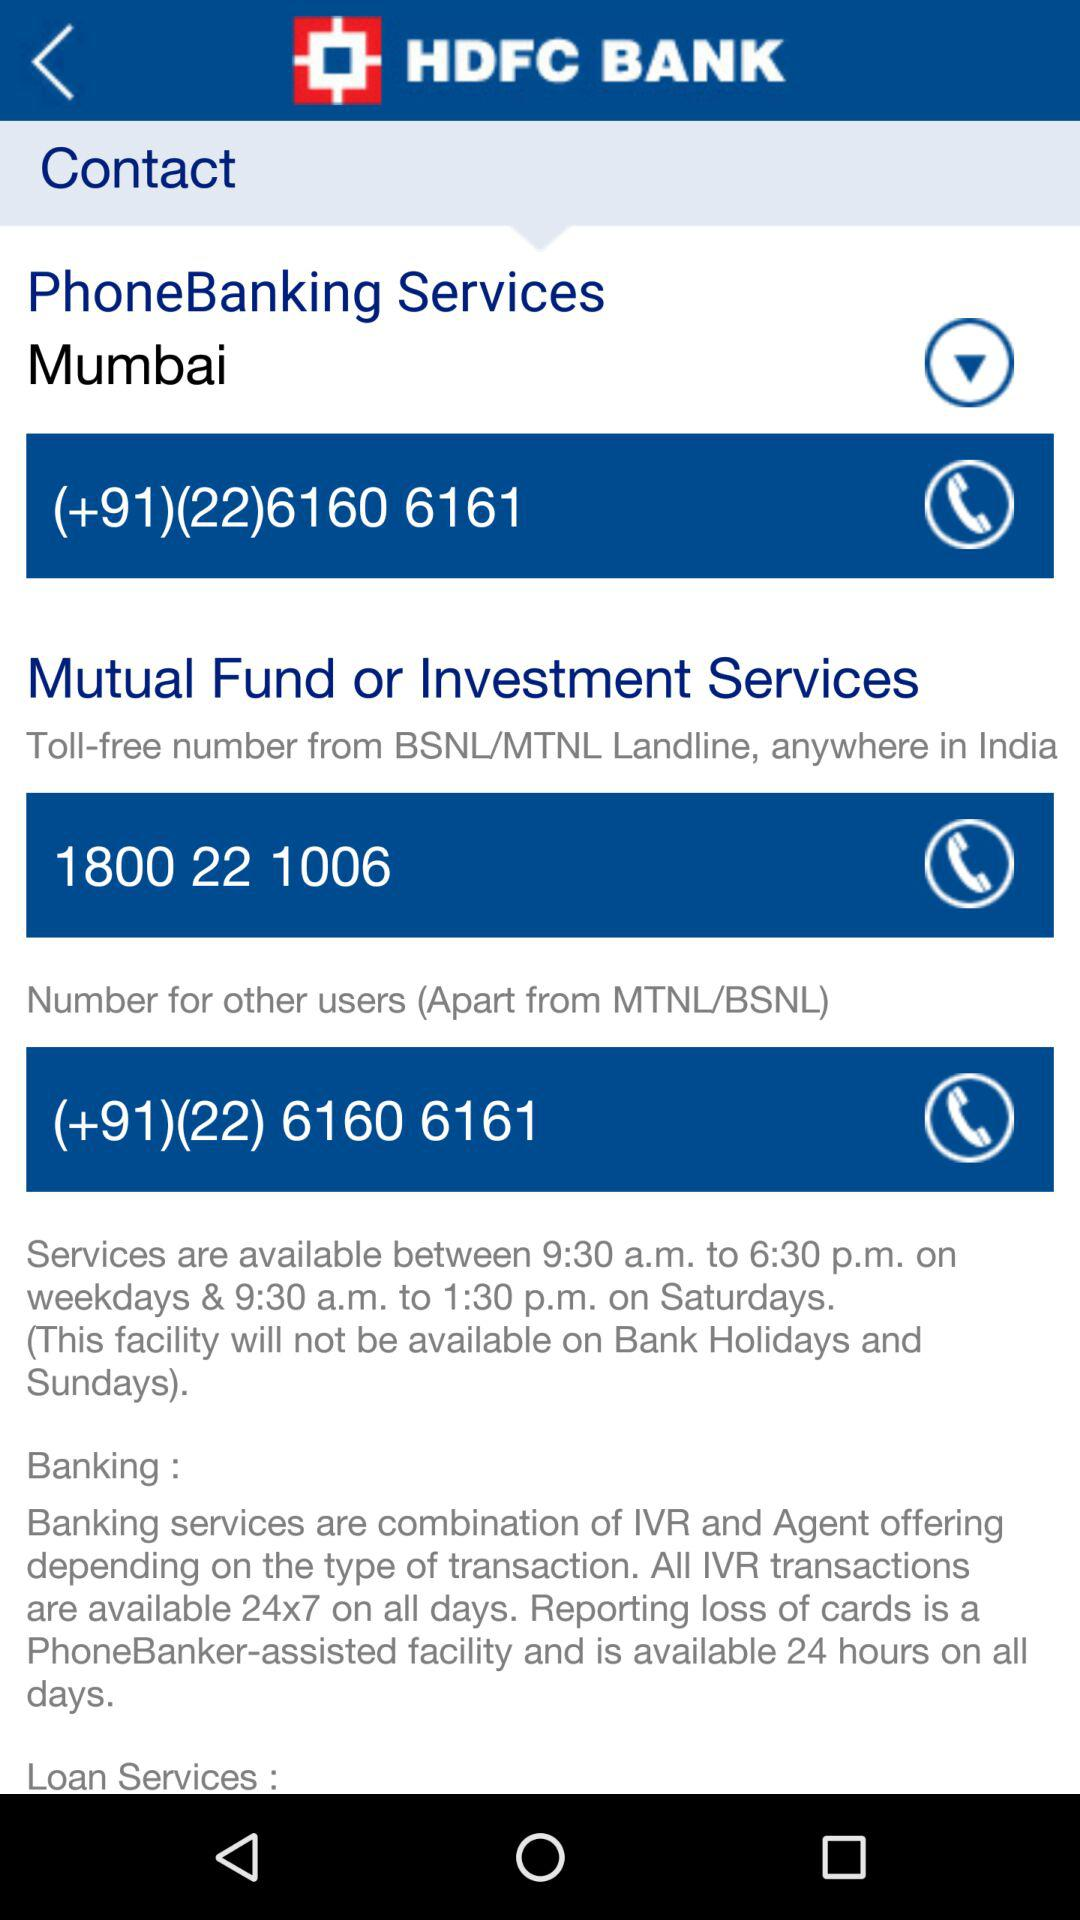What is the selected location? The selected location is Mumbai. 